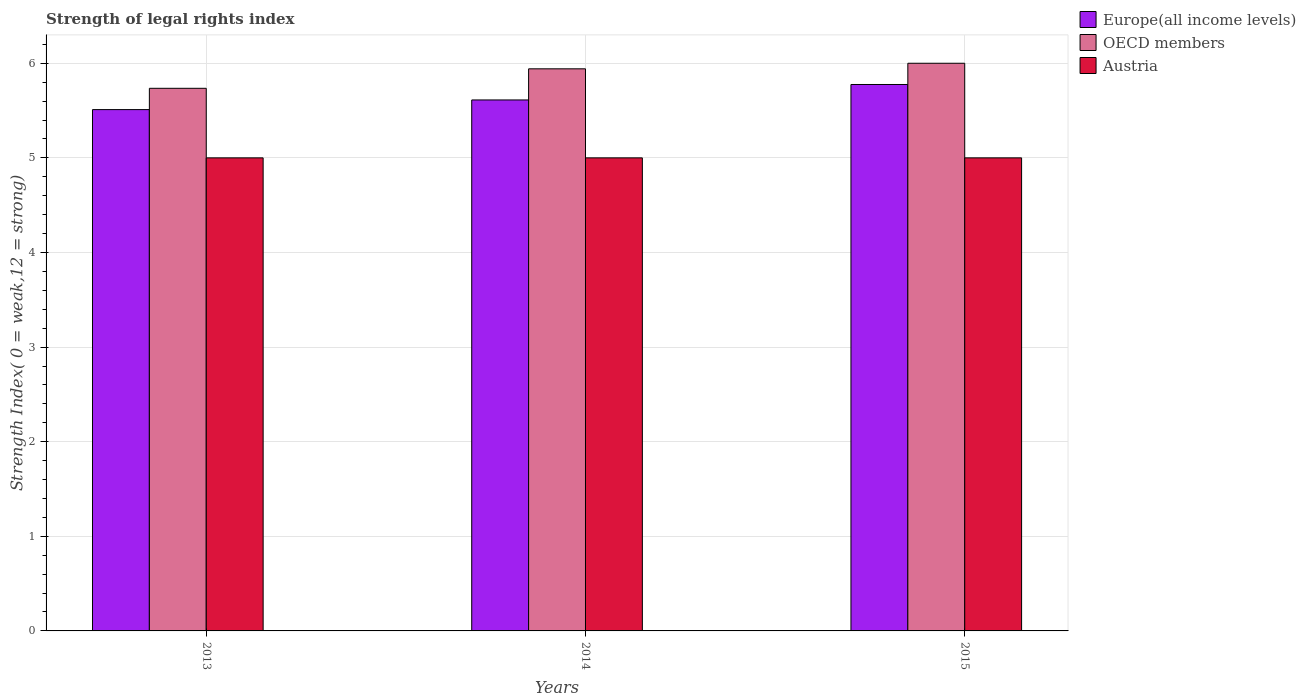How many different coloured bars are there?
Your response must be concise. 3. Are the number of bars on each tick of the X-axis equal?
Your response must be concise. Yes. How many bars are there on the 2nd tick from the right?
Your answer should be compact. 3. What is the label of the 3rd group of bars from the left?
Provide a short and direct response. 2015. In how many cases, is the number of bars for a given year not equal to the number of legend labels?
Your answer should be compact. 0. What is the strength index in OECD members in 2014?
Offer a very short reply. 5.94. Across all years, what is the minimum strength index in Austria?
Ensure brevity in your answer.  5. In which year was the strength index in Europe(all income levels) maximum?
Keep it short and to the point. 2015. What is the total strength index in OECD members in the graph?
Provide a short and direct response. 17.68. What is the difference between the strength index in Europe(all income levels) in 2013 and that in 2015?
Your answer should be compact. -0.27. What is the difference between the strength index in Austria in 2015 and the strength index in Europe(all income levels) in 2014?
Give a very brief answer. -0.61. What is the average strength index in OECD members per year?
Your answer should be very brief. 5.89. In the year 2014, what is the difference between the strength index in Austria and strength index in OECD members?
Your response must be concise. -0.94. Is the strength index in Austria in 2013 less than that in 2014?
Offer a terse response. No. Is the difference between the strength index in Austria in 2014 and 2015 greater than the difference between the strength index in OECD members in 2014 and 2015?
Offer a terse response. Yes. What is the difference between the highest and the second highest strength index in Europe(all income levels)?
Offer a very short reply. 0.16. What is the difference between the highest and the lowest strength index in Austria?
Offer a terse response. 0. Is the sum of the strength index in Europe(all income levels) in 2013 and 2015 greater than the maximum strength index in OECD members across all years?
Make the answer very short. Yes. What does the 1st bar from the left in 2014 represents?
Your response must be concise. Europe(all income levels). Is it the case that in every year, the sum of the strength index in Europe(all income levels) and strength index in OECD members is greater than the strength index in Austria?
Your answer should be compact. Yes. How many years are there in the graph?
Your response must be concise. 3. What is the difference between two consecutive major ticks on the Y-axis?
Provide a short and direct response. 1. Are the values on the major ticks of Y-axis written in scientific E-notation?
Your response must be concise. No. Does the graph contain any zero values?
Give a very brief answer. No. Where does the legend appear in the graph?
Keep it short and to the point. Top right. How many legend labels are there?
Ensure brevity in your answer.  3. What is the title of the graph?
Offer a terse response. Strength of legal rights index. Does "Congo (Republic)" appear as one of the legend labels in the graph?
Offer a terse response. No. What is the label or title of the X-axis?
Your response must be concise. Years. What is the label or title of the Y-axis?
Your answer should be compact. Strength Index( 0 = weak,12 = strong). What is the Strength Index( 0 = weak,12 = strong) of Europe(all income levels) in 2013?
Your answer should be very brief. 5.51. What is the Strength Index( 0 = weak,12 = strong) in OECD members in 2013?
Your answer should be very brief. 5.74. What is the Strength Index( 0 = weak,12 = strong) in Europe(all income levels) in 2014?
Provide a succinct answer. 5.61. What is the Strength Index( 0 = weak,12 = strong) of OECD members in 2014?
Provide a short and direct response. 5.94. What is the Strength Index( 0 = weak,12 = strong) in Austria in 2014?
Keep it short and to the point. 5. What is the Strength Index( 0 = weak,12 = strong) in Europe(all income levels) in 2015?
Provide a short and direct response. 5.78. What is the Strength Index( 0 = weak,12 = strong) in Austria in 2015?
Your answer should be compact. 5. Across all years, what is the maximum Strength Index( 0 = weak,12 = strong) of Europe(all income levels)?
Offer a terse response. 5.78. Across all years, what is the minimum Strength Index( 0 = weak,12 = strong) of Europe(all income levels)?
Provide a short and direct response. 5.51. Across all years, what is the minimum Strength Index( 0 = weak,12 = strong) in OECD members?
Your answer should be very brief. 5.74. What is the total Strength Index( 0 = weak,12 = strong) in Europe(all income levels) in the graph?
Give a very brief answer. 16.9. What is the total Strength Index( 0 = weak,12 = strong) of OECD members in the graph?
Provide a short and direct response. 17.68. What is the difference between the Strength Index( 0 = weak,12 = strong) of Europe(all income levels) in 2013 and that in 2014?
Your response must be concise. -0.1. What is the difference between the Strength Index( 0 = weak,12 = strong) of OECD members in 2013 and that in 2014?
Offer a very short reply. -0.21. What is the difference between the Strength Index( 0 = weak,12 = strong) of Austria in 2013 and that in 2014?
Offer a very short reply. 0. What is the difference between the Strength Index( 0 = weak,12 = strong) in Europe(all income levels) in 2013 and that in 2015?
Your answer should be very brief. -0.27. What is the difference between the Strength Index( 0 = weak,12 = strong) of OECD members in 2013 and that in 2015?
Keep it short and to the point. -0.26. What is the difference between the Strength Index( 0 = weak,12 = strong) in Austria in 2013 and that in 2015?
Your answer should be compact. 0. What is the difference between the Strength Index( 0 = weak,12 = strong) of Europe(all income levels) in 2014 and that in 2015?
Give a very brief answer. -0.16. What is the difference between the Strength Index( 0 = weak,12 = strong) of OECD members in 2014 and that in 2015?
Your response must be concise. -0.06. What is the difference between the Strength Index( 0 = weak,12 = strong) in Europe(all income levels) in 2013 and the Strength Index( 0 = weak,12 = strong) in OECD members in 2014?
Provide a short and direct response. -0.43. What is the difference between the Strength Index( 0 = weak,12 = strong) of Europe(all income levels) in 2013 and the Strength Index( 0 = weak,12 = strong) of Austria in 2014?
Provide a short and direct response. 0.51. What is the difference between the Strength Index( 0 = weak,12 = strong) of OECD members in 2013 and the Strength Index( 0 = weak,12 = strong) of Austria in 2014?
Ensure brevity in your answer.  0.74. What is the difference between the Strength Index( 0 = weak,12 = strong) in Europe(all income levels) in 2013 and the Strength Index( 0 = weak,12 = strong) in OECD members in 2015?
Offer a very short reply. -0.49. What is the difference between the Strength Index( 0 = weak,12 = strong) in Europe(all income levels) in 2013 and the Strength Index( 0 = weak,12 = strong) in Austria in 2015?
Offer a very short reply. 0.51. What is the difference between the Strength Index( 0 = weak,12 = strong) of OECD members in 2013 and the Strength Index( 0 = weak,12 = strong) of Austria in 2015?
Provide a succinct answer. 0.74. What is the difference between the Strength Index( 0 = weak,12 = strong) in Europe(all income levels) in 2014 and the Strength Index( 0 = weak,12 = strong) in OECD members in 2015?
Your answer should be compact. -0.39. What is the difference between the Strength Index( 0 = weak,12 = strong) of Europe(all income levels) in 2014 and the Strength Index( 0 = weak,12 = strong) of Austria in 2015?
Your answer should be very brief. 0.61. What is the average Strength Index( 0 = weak,12 = strong) in Europe(all income levels) per year?
Provide a short and direct response. 5.63. What is the average Strength Index( 0 = weak,12 = strong) of OECD members per year?
Your response must be concise. 5.89. What is the average Strength Index( 0 = weak,12 = strong) in Austria per year?
Your answer should be compact. 5. In the year 2013, what is the difference between the Strength Index( 0 = weak,12 = strong) in Europe(all income levels) and Strength Index( 0 = weak,12 = strong) in OECD members?
Ensure brevity in your answer.  -0.23. In the year 2013, what is the difference between the Strength Index( 0 = weak,12 = strong) in Europe(all income levels) and Strength Index( 0 = weak,12 = strong) in Austria?
Ensure brevity in your answer.  0.51. In the year 2013, what is the difference between the Strength Index( 0 = weak,12 = strong) in OECD members and Strength Index( 0 = weak,12 = strong) in Austria?
Your answer should be compact. 0.74. In the year 2014, what is the difference between the Strength Index( 0 = weak,12 = strong) in Europe(all income levels) and Strength Index( 0 = weak,12 = strong) in OECD members?
Offer a terse response. -0.33. In the year 2014, what is the difference between the Strength Index( 0 = weak,12 = strong) of Europe(all income levels) and Strength Index( 0 = weak,12 = strong) of Austria?
Offer a terse response. 0.61. In the year 2014, what is the difference between the Strength Index( 0 = weak,12 = strong) in OECD members and Strength Index( 0 = weak,12 = strong) in Austria?
Offer a terse response. 0.94. In the year 2015, what is the difference between the Strength Index( 0 = weak,12 = strong) in Europe(all income levels) and Strength Index( 0 = weak,12 = strong) in OECD members?
Make the answer very short. -0.22. In the year 2015, what is the difference between the Strength Index( 0 = weak,12 = strong) of Europe(all income levels) and Strength Index( 0 = weak,12 = strong) of Austria?
Your response must be concise. 0.78. In the year 2015, what is the difference between the Strength Index( 0 = weak,12 = strong) in OECD members and Strength Index( 0 = weak,12 = strong) in Austria?
Provide a short and direct response. 1. What is the ratio of the Strength Index( 0 = weak,12 = strong) in Europe(all income levels) in 2013 to that in 2014?
Your response must be concise. 0.98. What is the ratio of the Strength Index( 0 = weak,12 = strong) in OECD members in 2013 to that in 2014?
Your answer should be very brief. 0.97. What is the ratio of the Strength Index( 0 = weak,12 = strong) of Europe(all income levels) in 2013 to that in 2015?
Provide a short and direct response. 0.95. What is the ratio of the Strength Index( 0 = weak,12 = strong) in OECD members in 2013 to that in 2015?
Your answer should be very brief. 0.96. What is the ratio of the Strength Index( 0 = weak,12 = strong) of Europe(all income levels) in 2014 to that in 2015?
Offer a very short reply. 0.97. What is the ratio of the Strength Index( 0 = weak,12 = strong) of OECD members in 2014 to that in 2015?
Keep it short and to the point. 0.99. What is the ratio of the Strength Index( 0 = weak,12 = strong) of Austria in 2014 to that in 2015?
Make the answer very short. 1. What is the difference between the highest and the second highest Strength Index( 0 = weak,12 = strong) of Europe(all income levels)?
Give a very brief answer. 0.16. What is the difference between the highest and the second highest Strength Index( 0 = weak,12 = strong) of OECD members?
Give a very brief answer. 0.06. What is the difference between the highest and the second highest Strength Index( 0 = weak,12 = strong) in Austria?
Ensure brevity in your answer.  0. What is the difference between the highest and the lowest Strength Index( 0 = weak,12 = strong) in Europe(all income levels)?
Offer a very short reply. 0.27. What is the difference between the highest and the lowest Strength Index( 0 = weak,12 = strong) of OECD members?
Your response must be concise. 0.26. 